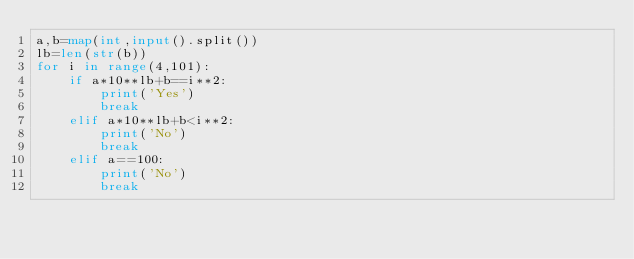Convert code to text. <code><loc_0><loc_0><loc_500><loc_500><_Python_>a,b=map(int,input().split())
lb=len(str(b))
for i in range(4,101):
    if a*10**lb+b==i**2:
        print('Yes')
        break
    elif a*10**lb+b<i**2:
        print('No')
        break
    elif a==100:
        print('No')
        break</code> 